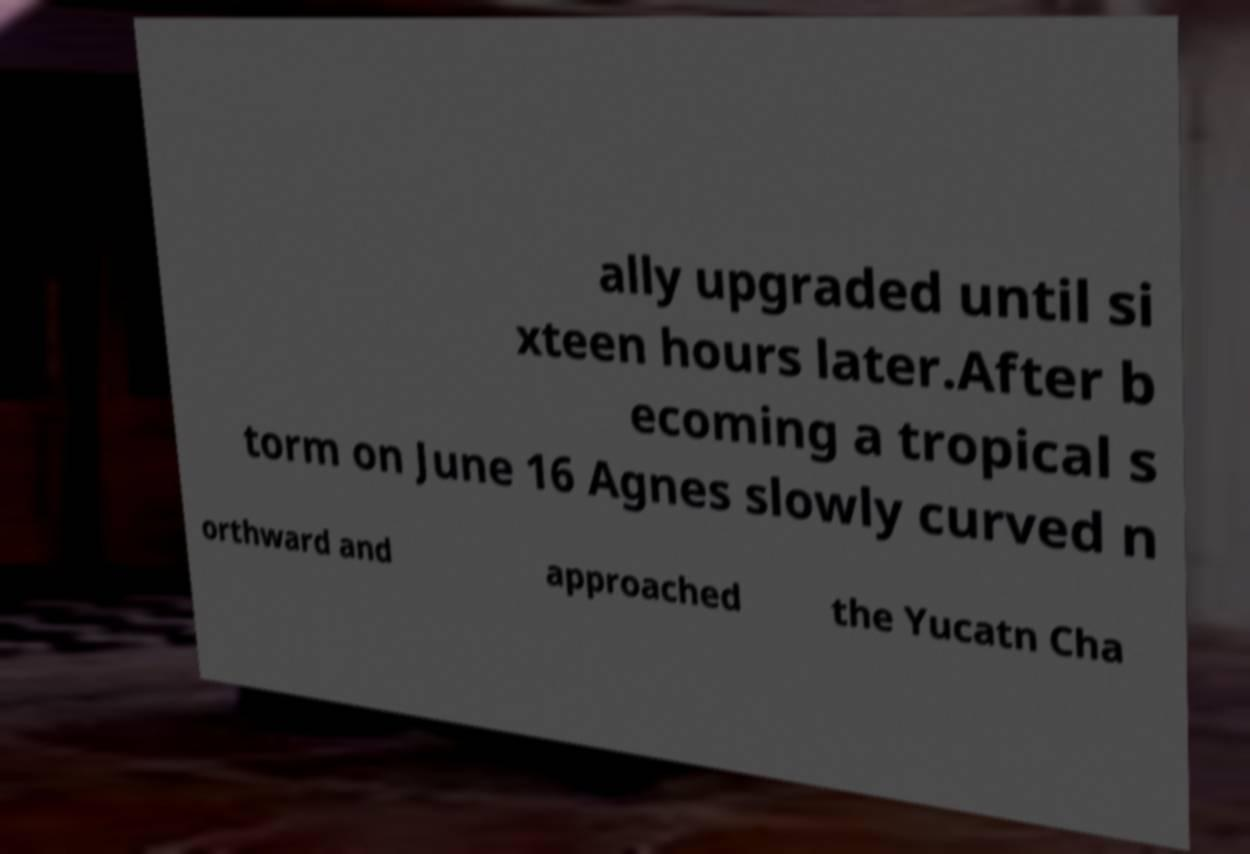Could you assist in decoding the text presented in this image and type it out clearly? ally upgraded until si xteen hours later.After b ecoming a tropical s torm on June 16 Agnes slowly curved n orthward and approached the Yucatn Cha 